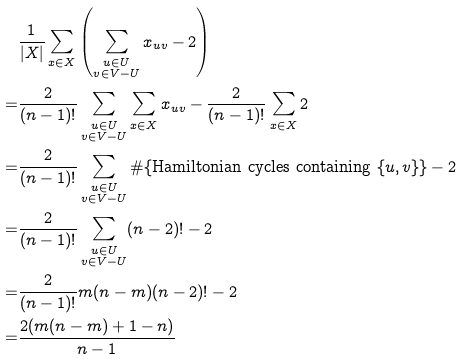Convert formula to latex. <formula><loc_0><loc_0><loc_500><loc_500>& \frac { 1 } { | X | } \sum _ { x \in X } \left ( \sum _ { \substack { u \in U \\ v \in V - U } } x _ { u v } - 2 \right ) \\ = & \frac { 2 } { ( n - 1 ) ! } \sum _ { \substack { u \in U \\ v \in V - U } } \sum _ { x \in X } x _ { u v } - \frac { 2 } { ( n - 1 ) ! } \sum _ { x \in X } 2 \\ = & \frac { 2 } { ( n - 1 ) ! } \sum _ { \substack { u \in U \\ v \in V - U } } \# \{ \text {Hamiltonian cycles containing } \{ u , v \} \} - 2 \\ = & \frac { 2 } { ( n - 1 ) ! } \sum _ { \substack { u \in U \\ v \in V - U } } ( n - 2 ) ! - 2 \\ = & \frac { 2 } { ( n - 1 ) ! } m ( n - m ) ( n - 2 ) ! - 2 \\ = & \frac { 2 ( m ( n - m ) + 1 - n ) } { n - 1 }</formula> 